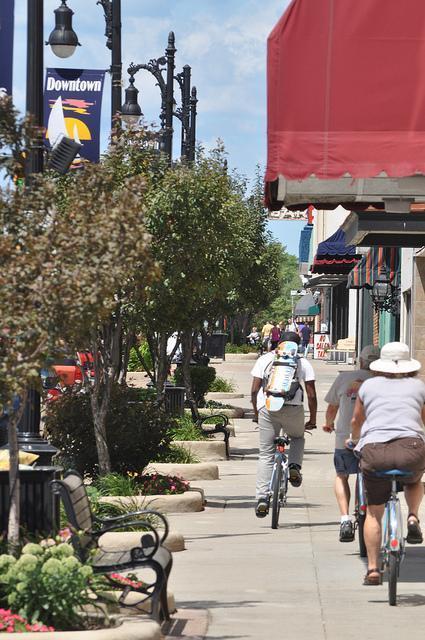How many people are there?
Give a very brief answer. 3. How many benches can be seen?
Give a very brief answer. 1. How many potted plants are there?
Give a very brief answer. 1. 